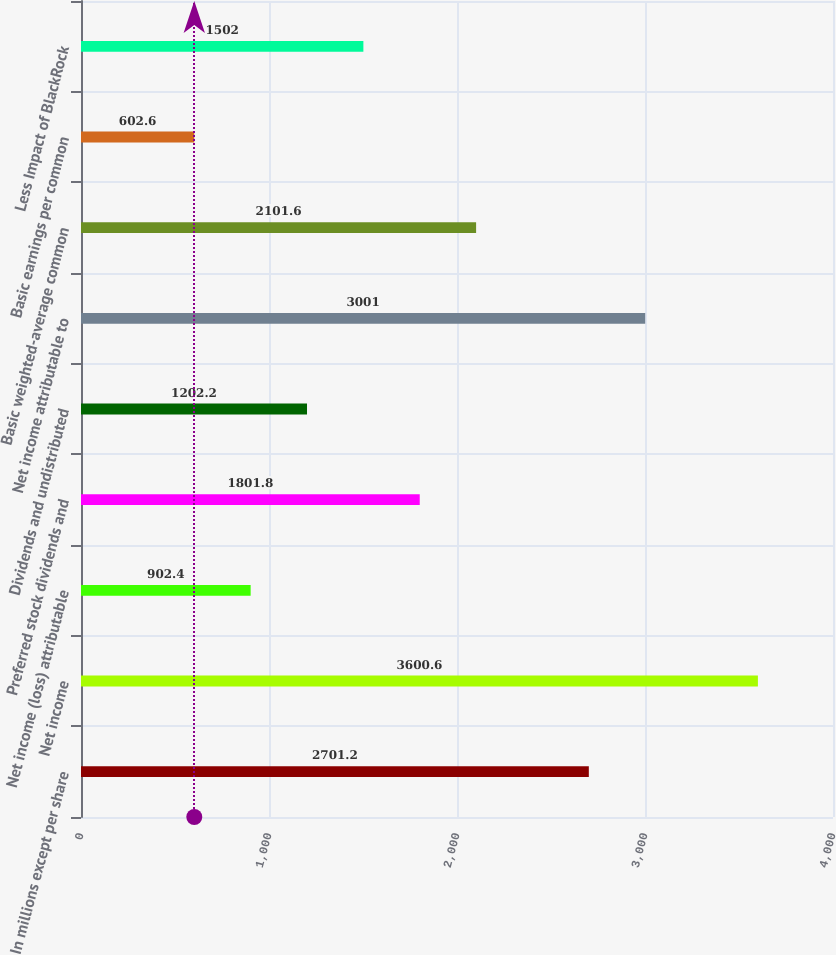<chart> <loc_0><loc_0><loc_500><loc_500><bar_chart><fcel>In millions except per share<fcel>Net income<fcel>Net income (loss) attributable<fcel>Preferred stock dividends and<fcel>Dividends and undistributed<fcel>Net income attributable to<fcel>Basic weighted-average common<fcel>Basic earnings per common<fcel>Less Impact of BlackRock<nl><fcel>2701.2<fcel>3600.6<fcel>902.4<fcel>1801.8<fcel>1202.2<fcel>3001<fcel>2101.6<fcel>602.6<fcel>1502<nl></chart> 